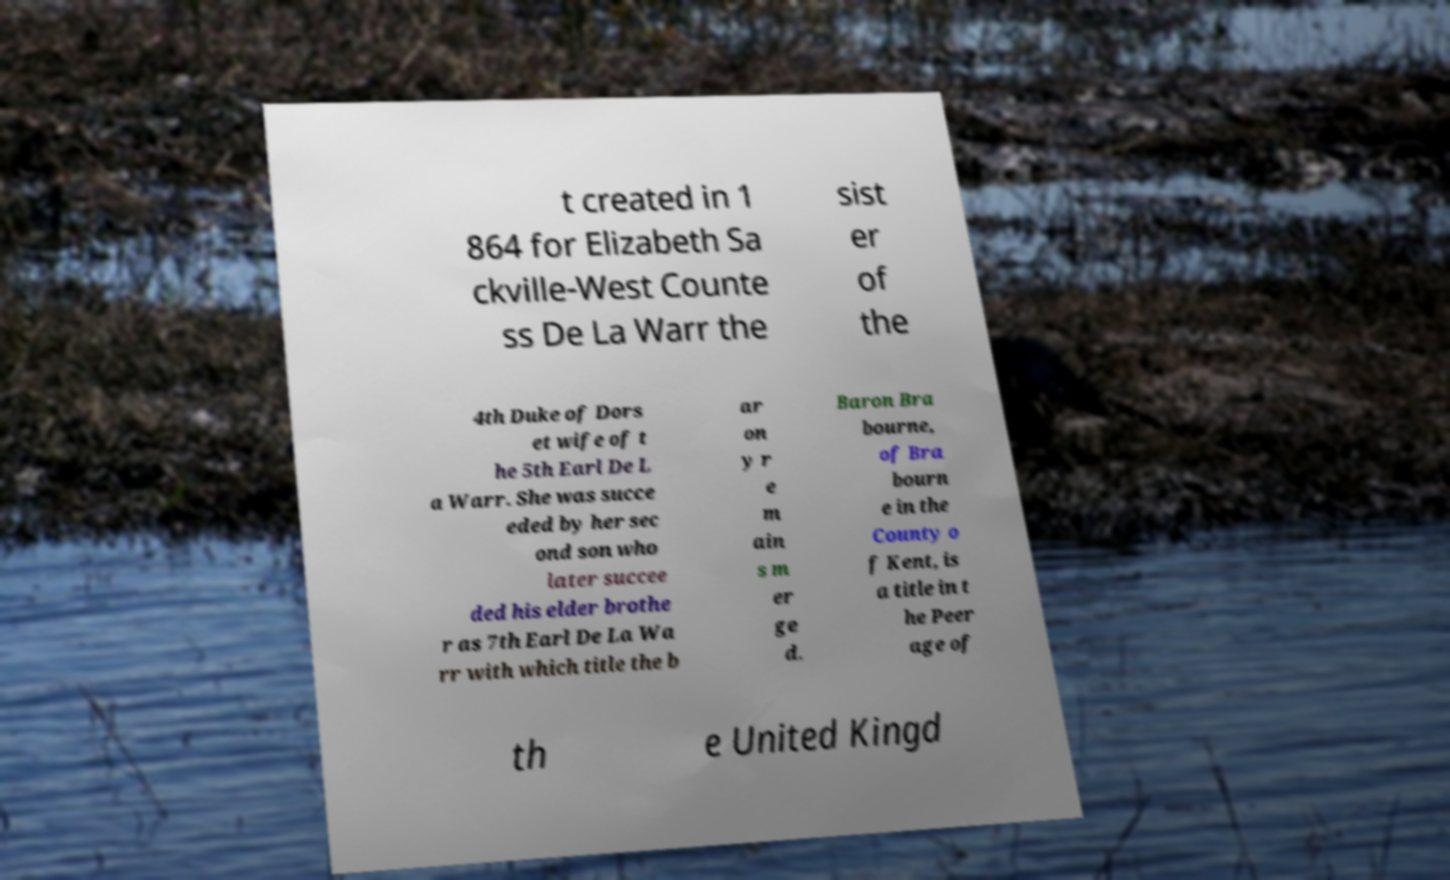There's text embedded in this image that I need extracted. Can you transcribe it verbatim? t created in 1 864 for Elizabeth Sa ckville-West Counte ss De La Warr the sist er of the 4th Duke of Dors et wife of t he 5th Earl De L a Warr. She was succe eded by her sec ond son who later succee ded his elder brothe r as 7th Earl De La Wa rr with which title the b ar on y r e m ain s m er ge d. Baron Bra bourne, of Bra bourn e in the County o f Kent, is a title in t he Peer age of th e United Kingd 